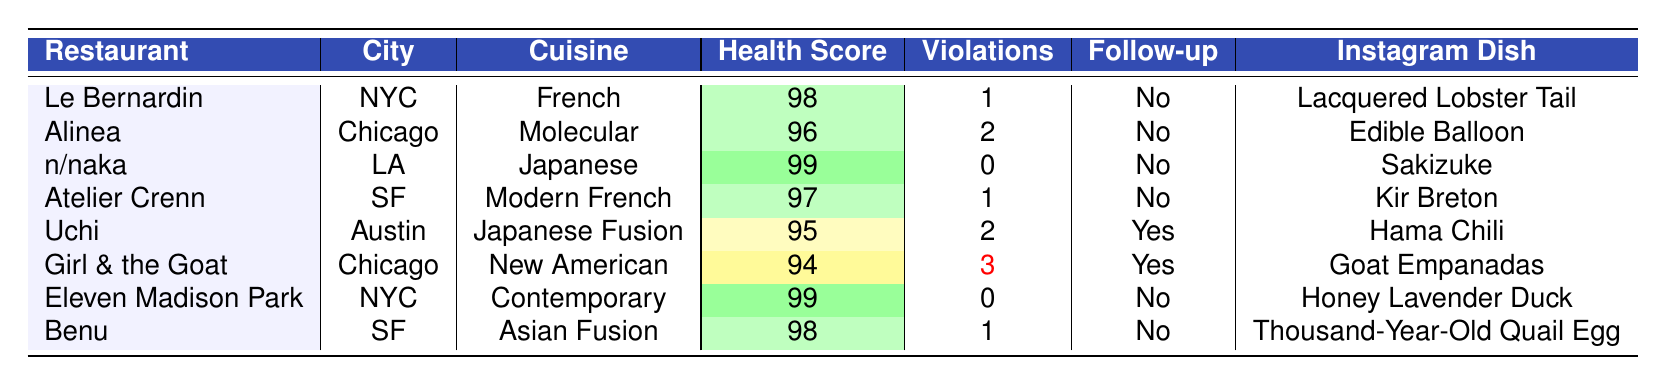What is the health score of n/naka? The table shows that n/naka has a health score of 99.
Answer: 99 How many total violations do Uchi and Girl & the Goat have combined? Uchi has 2 violations and Girl & the Goat has 3 violations, so the total is 2 + 3 = 5.
Answer: 5 Is follow-up required for Atelier Crenn? The table indicates that follow-up is not required for Atelier Crenn.
Answer: No Which restaurant has the highest health score? The table indicates that both n/naka and Eleven Madison Park have the highest health score of 99.
Answer: n/naka and Eleven Madison Park How many restaurants have a health score below 96? The restaurants with health scores below 96 are Uchi (95) and Girl & the Goat (94), totaling 2 restaurants.
Answer: 2 What is the average health score of all the restaurants listed? The health scores are 98, 96, 99, 97, 95, 94, 99, and 98. Summing these gives 776, and since there are 8 restaurants, the average is 776 / 8 = 97.
Answer: 97 Does Girl & the Goat have any critical violations? Yes, the table shows that Girl & the Goat has 1 critical violation.
Answer: Yes Which restaurant has the most violations? Girl & the Goat has the most violations with a total of 3.
Answer: Girl & the Goat How many restaurants require follow-up based on their inspections? Uchi and Girl & the Goat require follow-up, which totals 2 restaurants.
Answer: 2 Are there any restaurants with a health score of 98 or higher that do not require follow-up? Yes, Le Bernardin, n/naka, and Eleven Madison Park have health scores of 98 or higher without requiring follow-up.
Answer: Yes 